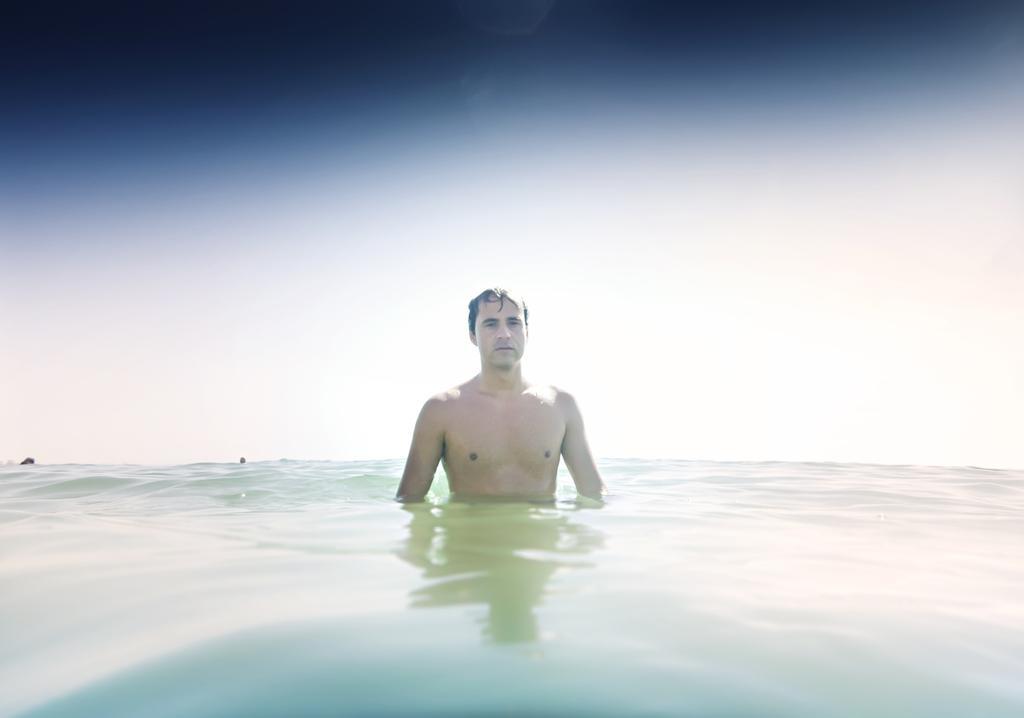Please provide a concise description of this image. There is a man in the water. In the background on the left we can see two objects on the water and this is a sky. 